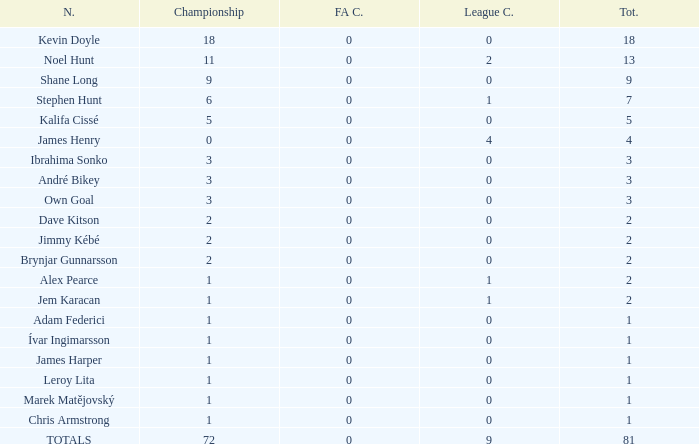What is the championship of Jem Karacan that has a total of 2 and a league cup more than 0? 1.0. 